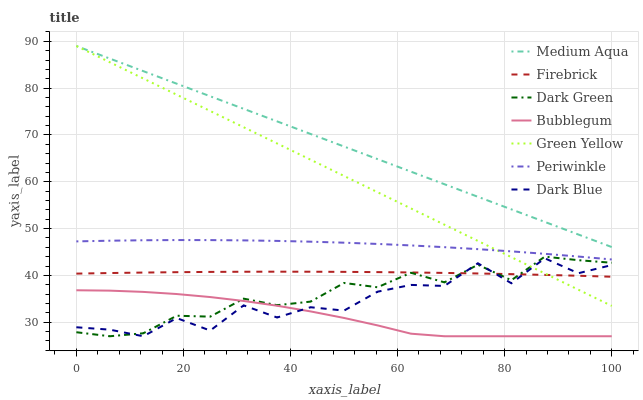Does Bubblegum have the minimum area under the curve?
Answer yes or no. Yes. Does Medium Aqua have the maximum area under the curve?
Answer yes or no. Yes. Does Dark Blue have the minimum area under the curve?
Answer yes or no. No. Does Dark Blue have the maximum area under the curve?
Answer yes or no. No. Is Green Yellow the smoothest?
Answer yes or no. Yes. Is Dark Blue the roughest?
Answer yes or no. Yes. Is Bubblegum the smoothest?
Answer yes or no. No. Is Bubblegum the roughest?
Answer yes or no. No. Does Bubblegum have the lowest value?
Answer yes or no. Yes. Does Periwinkle have the lowest value?
Answer yes or no. No. Does Green Yellow have the highest value?
Answer yes or no. Yes. Does Dark Blue have the highest value?
Answer yes or no. No. Is Dark Blue less than Medium Aqua?
Answer yes or no. Yes. Is Medium Aqua greater than Firebrick?
Answer yes or no. Yes. Does Dark Green intersect Green Yellow?
Answer yes or no. Yes. Is Dark Green less than Green Yellow?
Answer yes or no. No. Is Dark Green greater than Green Yellow?
Answer yes or no. No. Does Dark Blue intersect Medium Aqua?
Answer yes or no. No. 